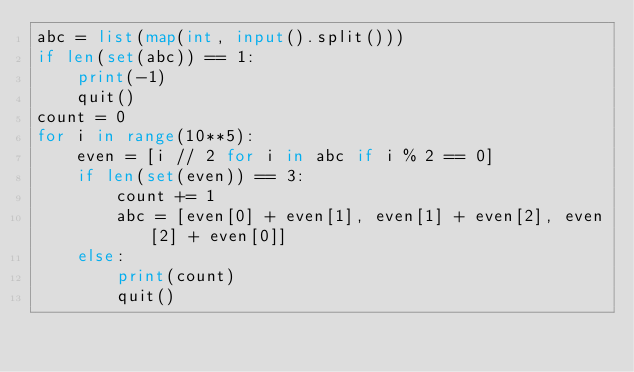<code> <loc_0><loc_0><loc_500><loc_500><_Python_>abc = list(map(int, input().split()))
if len(set(abc)) == 1:
    print(-1)
    quit()
count = 0
for i in range(10**5):
    even = [i // 2 for i in abc if i % 2 == 0]
    if len(set(even)) == 3:
        count += 1
        abc = [even[0] + even[1], even[1] + even[2], even[2] + even[0]]
    else:
        print(count)
        quit()</code> 